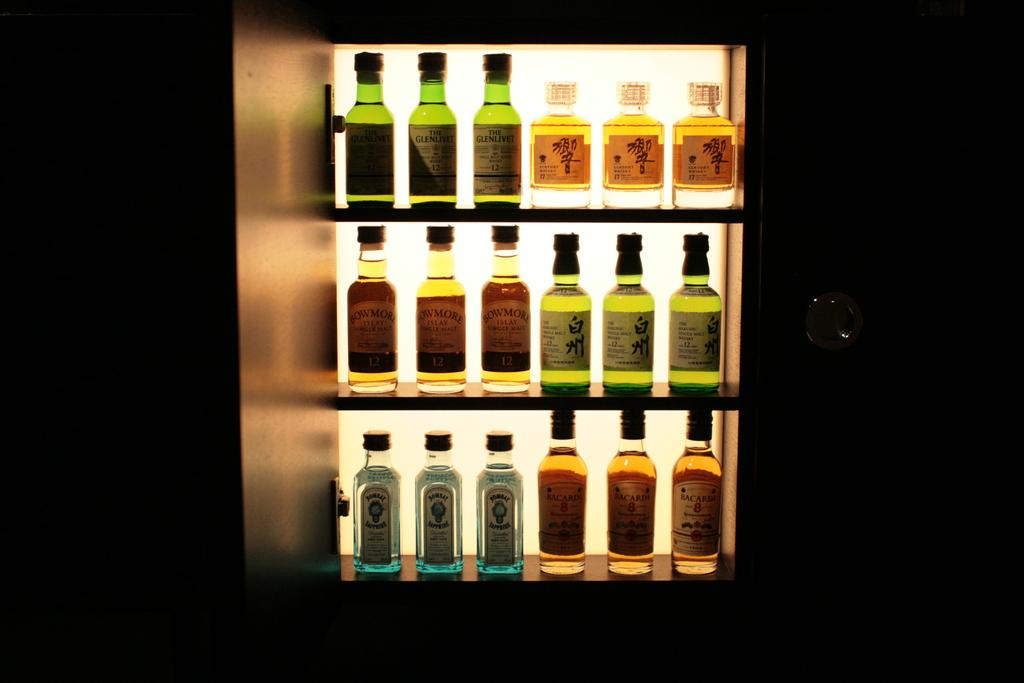What type of bottles are in the rack in the image? There are wine bottles in the rack in the image. How are the wine bottles arranged in the image? The wine bottles are arranged in a rack in the image. What type of powder can be seen on the wine bottles in the image? There is no powder visible on the wine bottles in the image. What message of peace is conveyed by the wine bottles in the image? The image does not convey any message of peace, as it only shows wine bottles in a rack. 